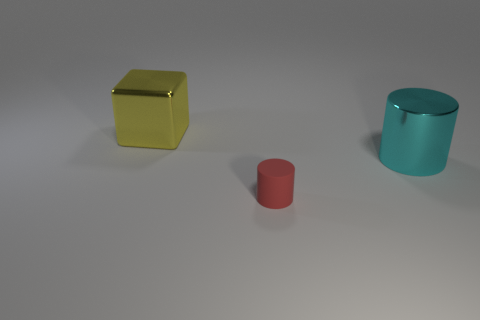How many objects are both to the right of the big yellow metallic thing and behind the small rubber object?
Your response must be concise. 1. There is a red object; what shape is it?
Provide a short and direct response. Cylinder. How many other objects are the same material as the big cylinder?
Your answer should be very brief. 1. There is a big thing that is to the right of the large metal object behind the metal object that is in front of the large yellow shiny cube; what color is it?
Your response must be concise. Cyan. There is a cyan cylinder that is the same size as the yellow cube; what is its material?
Provide a short and direct response. Metal. How many things are either large metallic things behind the big cyan thing or tiny blue rubber things?
Provide a succinct answer. 1. Are there any small red balls?
Your response must be concise. No. What material is the big thing right of the big yellow metal thing?
Make the answer very short. Metal. How many large objects are cyan metal cylinders or brown rubber spheres?
Keep it short and to the point. 1. What color is the matte thing?
Offer a very short reply. Red. 